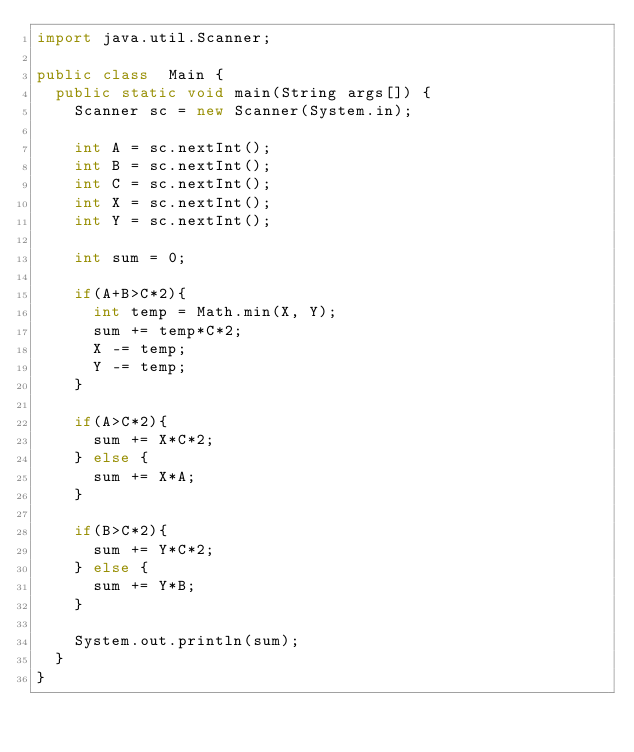Convert code to text. <code><loc_0><loc_0><loc_500><loc_500><_Java_>import java.util.Scanner;

public class  Main {
  public static void main(String args[]) {
    Scanner sc = new Scanner(System.in);

    int A = sc.nextInt();
    int B = sc.nextInt();
    int C = sc.nextInt();
    int X = sc.nextInt();
    int Y = sc.nextInt();
    
    int sum = 0;
    
    if(A+B>C*2){
      int temp = Math.min(X, Y);
      sum += temp*C*2;
      X -= temp;
      Y -= temp;
    }
    
    if(A>C*2){
      sum += X*C*2;
    } else {
      sum += X*A;
    }
    
    if(B>C*2){
      sum += Y*C*2;
    } else {
      sum += Y*B;
    }
    
    System.out.println(sum);
  }
}
        </code> 